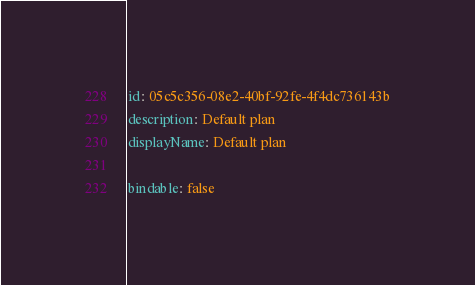<code> <loc_0><loc_0><loc_500><loc_500><_YAML_>id: 05c5c356-08e2-40bf-92fe-4f4dc736143b
description: Default plan
displayName: Default plan

bindable: false</code> 